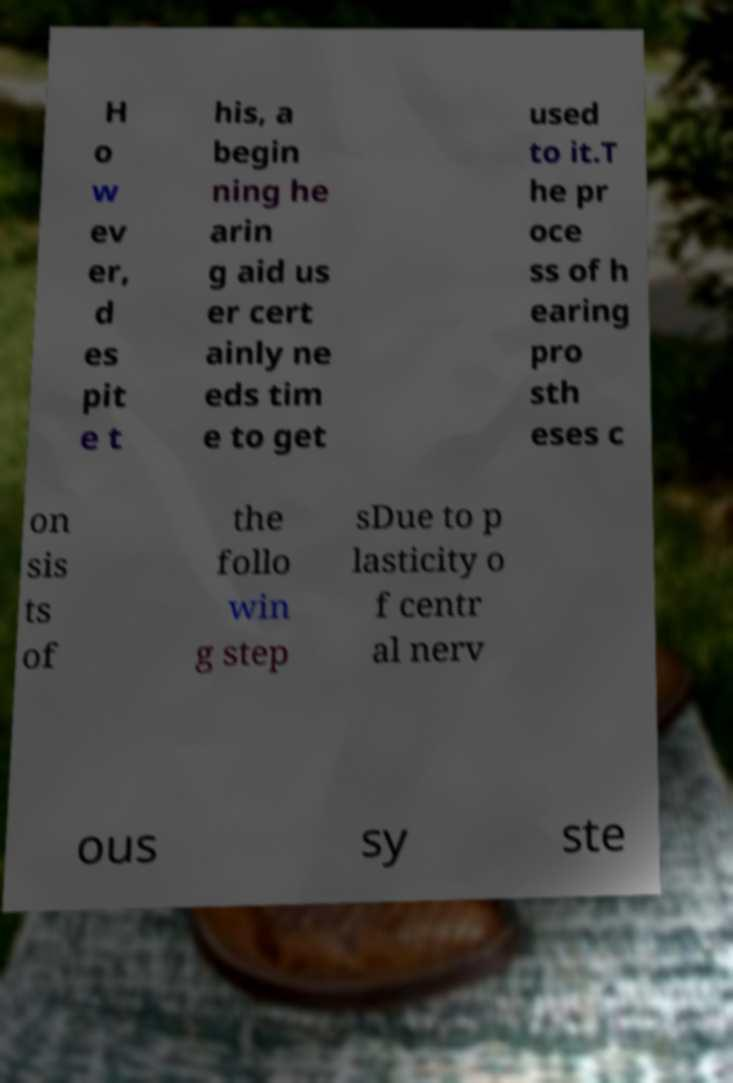Can you read and provide the text displayed in the image?This photo seems to have some interesting text. Can you extract and type it out for me? H o w ev er, d es pit e t his, a begin ning he arin g aid us er cert ainly ne eds tim e to get used to it.T he pr oce ss of h earing pro sth eses c on sis ts of the follo win g step sDue to p lasticity o f centr al nerv ous sy ste 